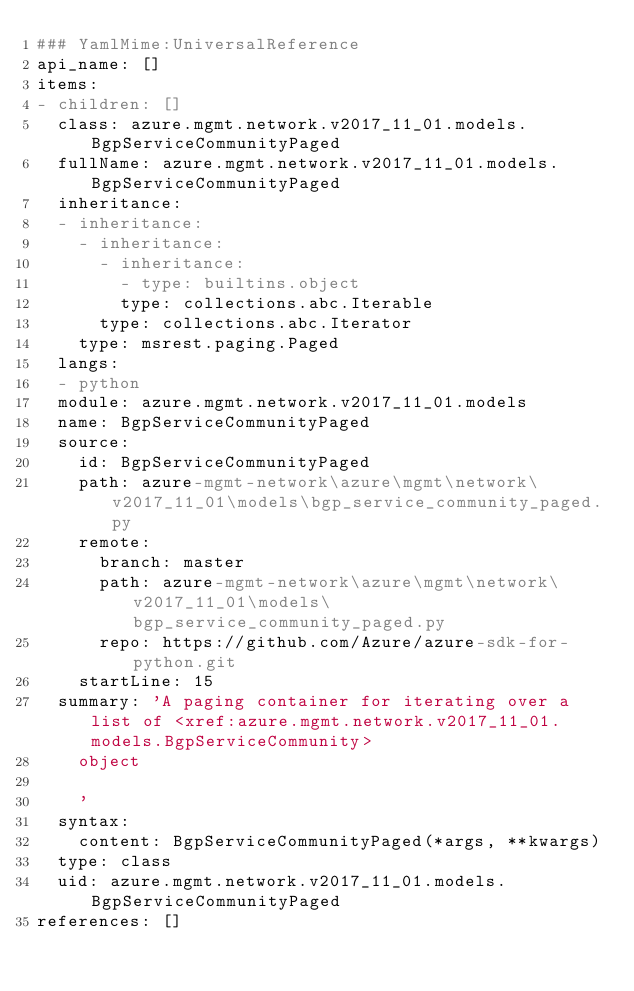Convert code to text. <code><loc_0><loc_0><loc_500><loc_500><_YAML_>### YamlMime:UniversalReference
api_name: []
items:
- children: []
  class: azure.mgmt.network.v2017_11_01.models.BgpServiceCommunityPaged
  fullName: azure.mgmt.network.v2017_11_01.models.BgpServiceCommunityPaged
  inheritance:
  - inheritance:
    - inheritance:
      - inheritance:
        - type: builtins.object
        type: collections.abc.Iterable
      type: collections.abc.Iterator
    type: msrest.paging.Paged
  langs:
  - python
  module: azure.mgmt.network.v2017_11_01.models
  name: BgpServiceCommunityPaged
  source:
    id: BgpServiceCommunityPaged
    path: azure-mgmt-network\azure\mgmt\network\v2017_11_01\models\bgp_service_community_paged.py
    remote:
      branch: master
      path: azure-mgmt-network\azure\mgmt\network\v2017_11_01\models\bgp_service_community_paged.py
      repo: https://github.com/Azure/azure-sdk-for-python.git
    startLine: 15
  summary: 'A paging container for iterating over a list of <xref:azure.mgmt.network.v2017_11_01.models.BgpServiceCommunity>
    object

    '
  syntax:
    content: BgpServiceCommunityPaged(*args, **kwargs)
  type: class
  uid: azure.mgmt.network.v2017_11_01.models.BgpServiceCommunityPaged
references: []
</code> 